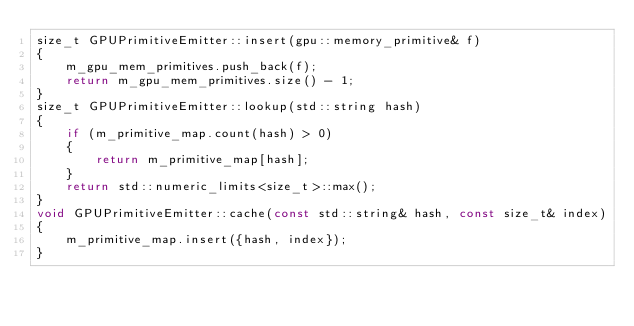Convert code to text. <code><loc_0><loc_0><loc_500><loc_500><_C++_>size_t GPUPrimitiveEmitter::insert(gpu::memory_primitive& f)
{
    m_gpu_mem_primitives.push_back(f);
    return m_gpu_mem_primitives.size() - 1;
}
size_t GPUPrimitiveEmitter::lookup(std::string hash)
{
    if (m_primitive_map.count(hash) > 0)
    {
        return m_primitive_map[hash];
    }
    return std::numeric_limits<size_t>::max();
}
void GPUPrimitiveEmitter::cache(const std::string& hash, const size_t& index)
{
    m_primitive_map.insert({hash, index});
}
</code> 